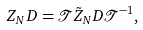<formula> <loc_0><loc_0><loc_500><loc_500>Z _ { N } D = \mathcal { T } \tilde { Z } _ { N } D \mathcal { T } ^ { - 1 } ,</formula> 